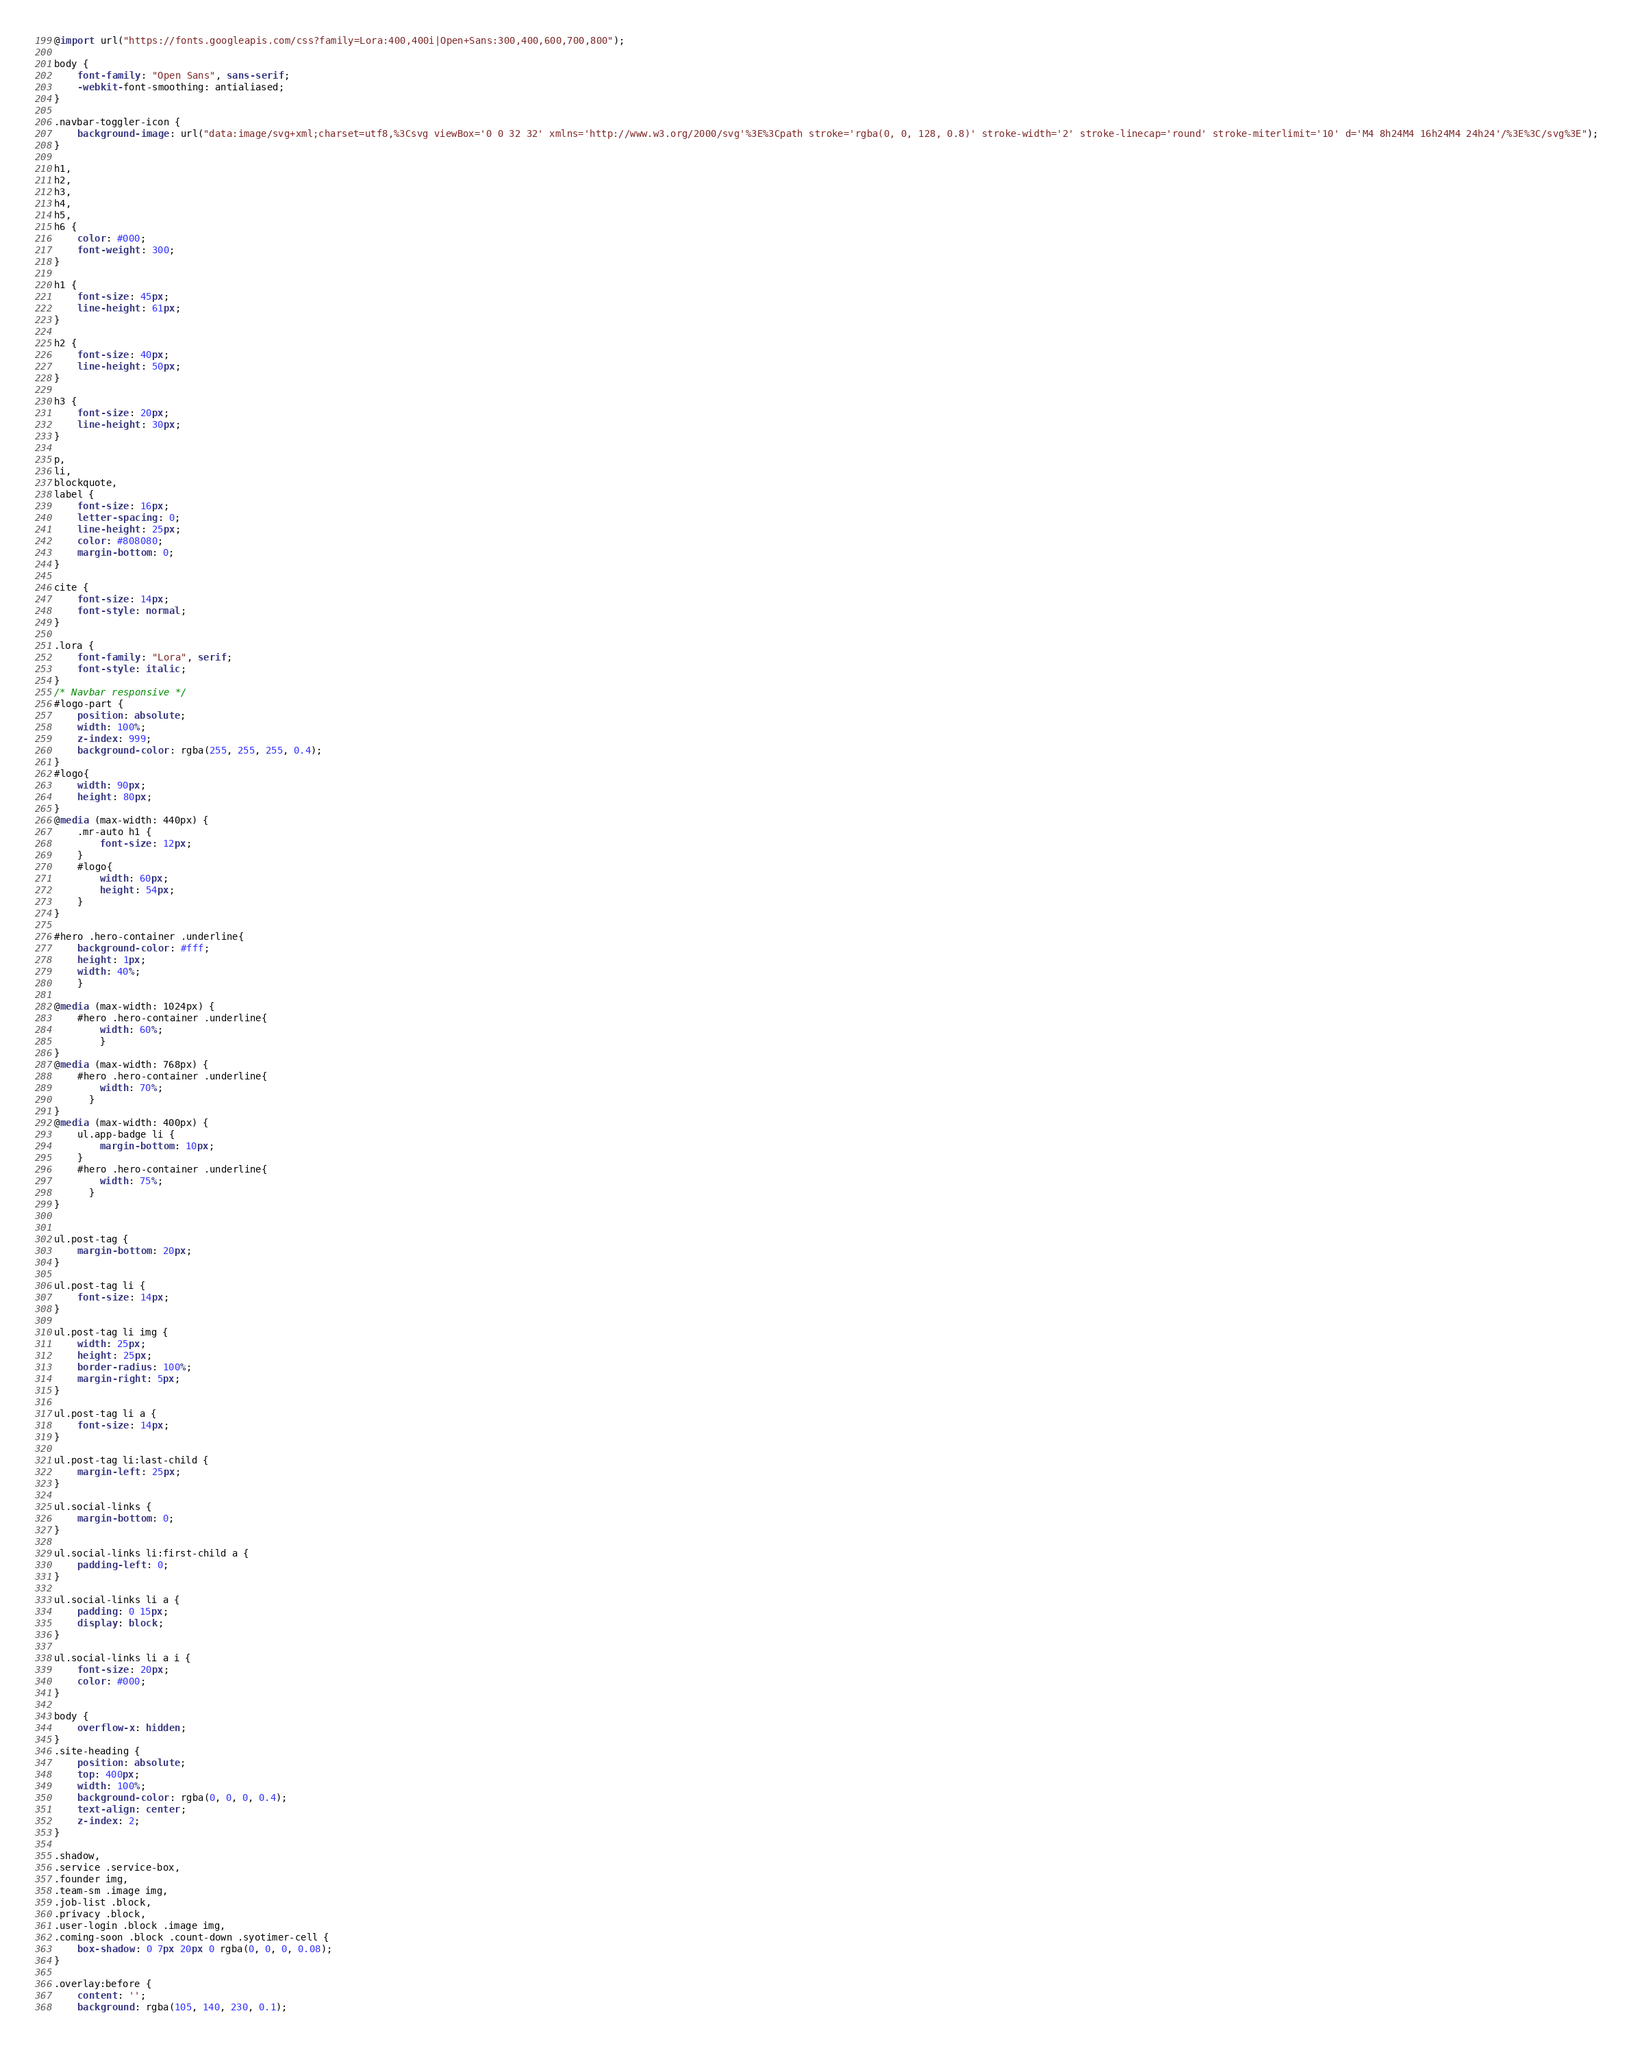Convert code to text. <code><loc_0><loc_0><loc_500><loc_500><_CSS_>@import url("https://fonts.googleapis.com/css?family=Lora:400,400i|Open+Sans:300,400,600,700,800");

body {
	font-family: "Open Sans", sans-serif;
	-webkit-font-smoothing: antialiased;
}

.navbar-toggler-icon {
	background-image: url("data:image/svg+xml;charset=utf8,%3Csvg viewBox='0 0 32 32' xmlns='http://www.w3.org/2000/svg'%3E%3Cpath stroke='rgba(0, 0, 128, 0.8)' stroke-width='2' stroke-linecap='round' stroke-miterlimit='10' d='M4 8h24M4 16h24M4 24h24'/%3E%3C/svg%3E");
}

h1,
h2,
h3,
h4,
h5,
h6 {
	color: #000;
	font-weight: 300;
}

h1 {
	font-size: 45px;
	line-height: 61px;
}

h2 {
	font-size: 40px;
	line-height: 50px;
}

h3 {
	font-size: 20px;
	line-height: 30px;
}

p,
li,
blockquote,
label {
	font-size: 16px;
	letter-spacing: 0;
	line-height: 25px;
	color: #808080;
	margin-bottom: 0;
}

cite {
	font-size: 14px;
	font-style: normal;
}

.lora {
	font-family: "Lora", serif;
	font-style: italic;
}
/* Navbar responsive */
#logo-part {
	position: absolute;
	width: 100%;
	z-index: 999;
	background-color: rgba(255, 255, 255, 0.4);
}
#logo{
	width: 90px;
	height: 80px;
}
@media (max-width: 440px) {
	.mr-auto h1 {
		font-size: 12px;
	}
	#logo{
		width: 60px;
		height: 54px;
	}
}

#hero .hero-container .underline{
	background-color: #fff;
	height: 1px;
	width: 40%;
	}

@media (max-width: 1024px) {
	#hero .hero-container .underline{
		width: 60%;
		}
}
@media (max-width: 768px) {
	#hero .hero-container .underline{
		width: 70%;
	  }
}
@media (max-width: 400px) {
	ul.app-badge li {
		margin-bottom: 10px;
	}
	#hero .hero-container .underline{
		width: 75%;
	  }
}


ul.post-tag {
	margin-bottom: 20px;
}

ul.post-tag li {
	font-size: 14px;
}

ul.post-tag li img {
	width: 25px;
	height: 25px;
	border-radius: 100%;
	margin-right: 5px;
}

ul.post-tag li a {
	font-size: 14px;
}

ul.post-tag li:last-child {
	margin-left: 25px;
}

ul.social-links {
	margin-bottom: 0;
}

ul.social-links li:first-child a {
	padding-left: 0;
}

ul.social-links li a {
	padding: 0 15px;
	display: block;
}

ul.social-links li a i {
	font-size: 20px;
	color: #000;
}

body {
	overflow-x: hidden;
}
.site-heading {
	position: absolute;
	top: 400px;
	width: 100%;
	background-color: rgba(0, 0, 0, 0.4);
	text-align: center;
	z-index: 2;
}

.shadow,
.service .service-box,
.founder img,
.team-sm .image img,
.job-list .block,
.privacy .block,
.user-login .block .image img,
.coming-soon .block .count-down .syotimer-cell {
	box-shadow: 0 7px 20px 0 rgba(0, 0, 0, 0.08);
}

.overlay:before {
	content: '';
	background: rgba(105, 140, 230, 0.1);</code> 